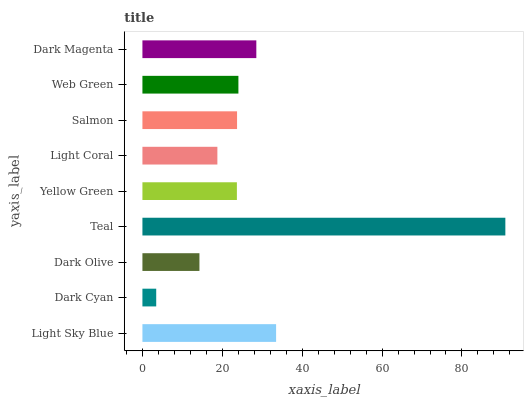Is Dark Cyan the minimum?
Answer yes or no. Yes. Is Teal the maximum?
Answer yes or no. Yes. Is Dark Olive the minimum?
Answer yes or no. No. Is Dark Olive the maximum?
Answer yes or no. No. Is Dark Olive greater than Dark Cyan?
Answer yes or no. Yes. Is Dark Cyan less than Dark Olive?
Answer yes or no. Yes. Is Dark Cyan greater than Dark Olive?
Answer yes or no. No. Is Dark Olive less than Dark Cyan?
Answer yes or no. No. Is Salmon the high median?
Answer yes or no. Yes. Is Salmon the low median?
Answer yes or no. Yes. Is Yellow Green the high median?
Answer yes or no. No. Is Teal the low median?
Answer yes or no. No. 